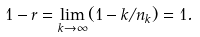<formula> <loc_0><loc_0><loc_500><loc_500>1 - r & = \lim _ { k \to \infty } ( 1 - k / n _ { k } ) = 1 .</formula> 